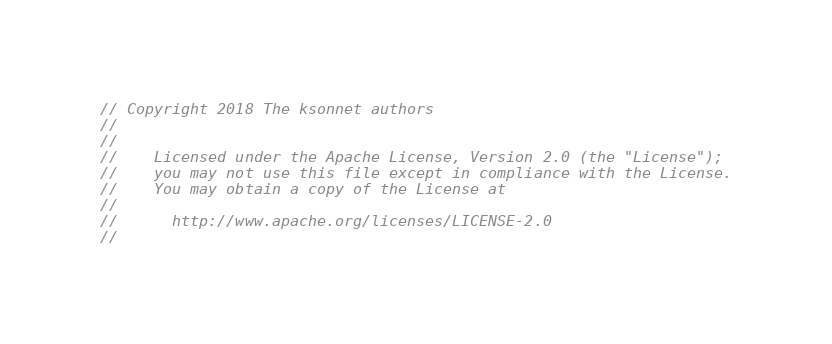<code> <loc_0><loc_0><loc_500><loc_500><_Go_>// Copyright 2018 The ksonnet authors
//
//
//    Licensed under the Apache License, Version 2.0 (the "License");
//    you may not use this file except in compliance with the License.
//    You may obtain a copy of the License at
//
//      http://www.apache.org/licenses/LICENSE-2.0
//</code> 